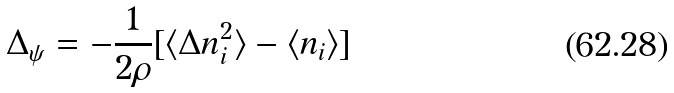Convert formula to latex. <formula><loc_0><loc_0><loc_500><loc_500>\Delta _ { \psi } = - \frac { 1 } { 2 \rho } [ \langle \Delta n _ { i } ^ { 2 } \rangle - \langle n _ { i } \rangle ]</formula> 